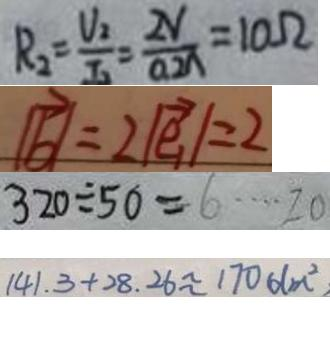<formula> <loc_0><loc_0><loc_500><loc_500>R _ { 2 } = \frac { V _ { 2 } } { I _ { 2 } } = \frac { 2 V } { 0 . 2 A } = 1 0 \Omega 
 \vert \overrightarrow { b } \vert = 2 \vert \overrightarrow { e _ { 1 } } \vert = 2 
 3 2 0 \div 5 0 = 6 \cdots 2 0 
 1 4 1 . 3 + 2 8 . 2 6 \approx 1 7 0 d m ^ { 2 }</formula> 